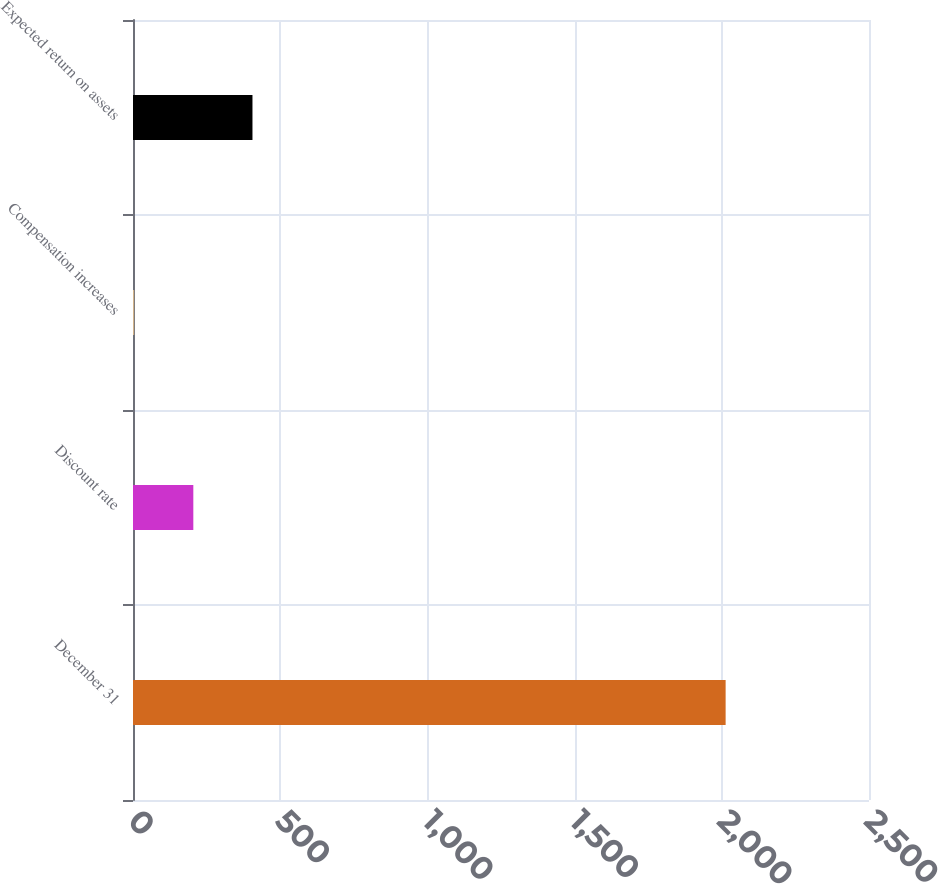Convert chart to OTSL. <chart><loc_0><loc_0><loc_500><loc_500><bar_chart><fcel>December 31<fcel>Discount rate<fcel>Compensation increases<fcel>Expected return on assets<nl><fcel>2013<fcel>204.9<fcel>4<fcel>405.8<nl></chart> 